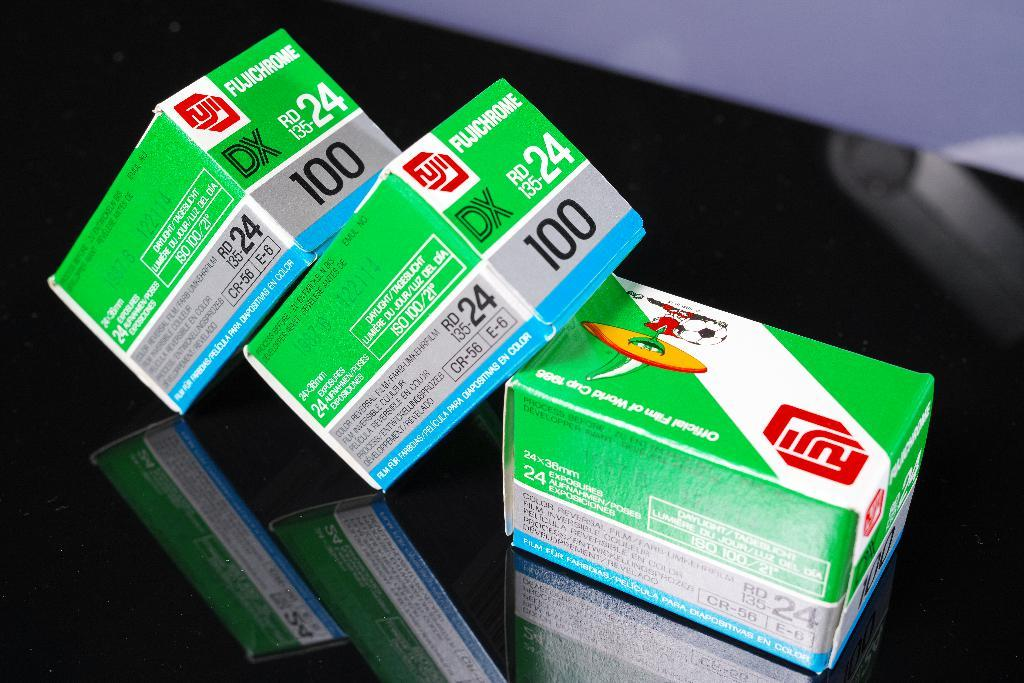<image>
Provide a brief description of the given image. Three boxes of Fuji film from 1987 sit together on a table. 